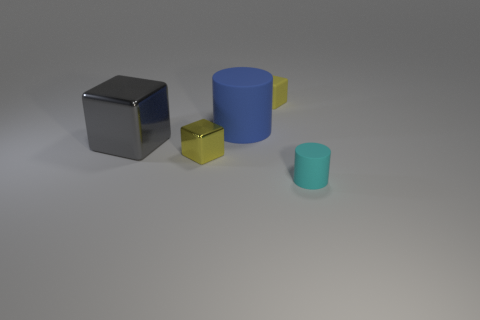Subtract all tiny shiny blocks. How many blocks are left? 2 Subtract all purple cylinders. How many gray cubes are left? 1 Subtract all gray cubes. How many cubes are left? 2 Subtract all cylinders. How many objects are left? 3 Subtract 1 blocks. How many blocks are left? 2 Subtract all gray cylinders. Subtract all gray spheres. How many cylinders are left? 2 Subtract all blue rubber objects. Subtract all small shiny cubes. How many objects are left? 3 Add 5 blue things. How many blue things are left? 6 Add 3 yellow cubes. How many yellow cubes exist? 5 Add 4 big green metallic things. How many objects exist? 9 